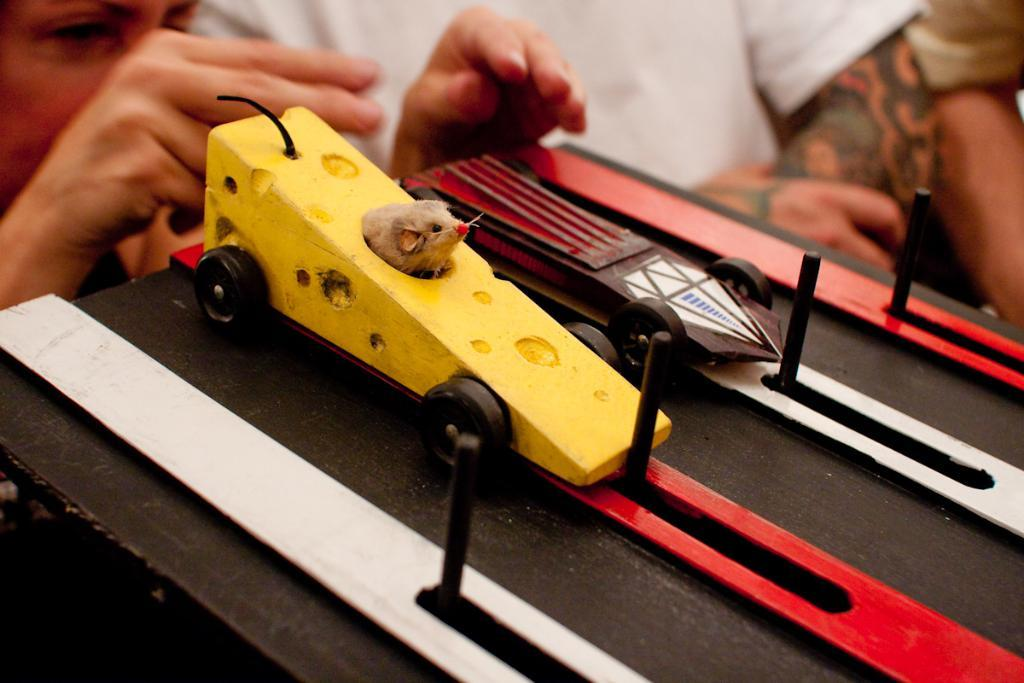Who is on the left side of the image? There is a person on the left side of the image. What can be seen on the board in the image? There are two cars placed on the board in the image. How many people are on the right side of the image? There are two other people standing on the right side of the image. What type of religious symbol can be seen on the board with the two cars? There is no religious symbol present on the board with the two cars; it only features two cars. 